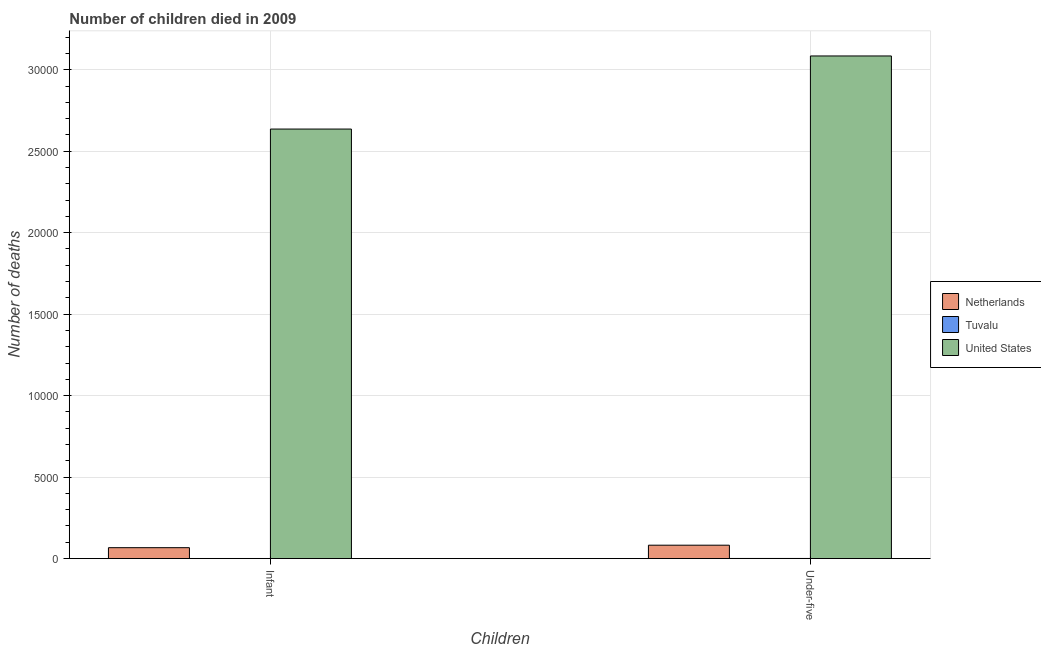Are the number of bars on each tick of the X-axis equal?
Provide a succinct answer. Yes. How many bars are there on the 2nd tick from the left?
Your answer should be very brief. 3. What is the label of the 2nd group of bars from the left?
Provide a short and direct response. Under-five. What is the number of under-five deaths in United States?
Make the answer very short. 3.08e+04. Across all countries, what is the maximum number of under-five deaths?
Provide a short and direct response. 3.08e+04. Across all countries, what is the minimum number of under-five deaths?
Make the answer very short. 7. In which country was the number of infant deaths minimum?
Your answer should be very brief. Tuvalu. What is the total number of infant deaths in the graph?
Provide a succinct answer. 2.70e+04. What is the difference between the number of infant deaths in Netherlands and that in United States?
Provide a short and direct response. -2.57e+04. What is the difference between the number of infant deaths in Tuvalu and the number of under-five deaths in United States?
Give a very brief answer. -3.08e+04. What is the average number of under-five deaths per country?
Offer a very short reply. 1.06e+04. What is the difference between the number of infant deaths and number of under-five deaths in Netherlands?
Your response must be concise. -153. What is the ratio of the number of infant deaths in Netherlands to that in Tuvalu?
Ensure brevity in your answer.  133.6. What does the 2nd bar from the left in Infant represents?
Your answer should be compact. Tuvalu. Are all the bars in the graph horizontal?
Make the answer very short. No. How many countries are there in the graph?
Keep it short and to the point. 3. What is the difference between two consecutive major ticks on the Y-axis?
Make the answer very short. 5000. Are the values on the major ticks of Y-axis written in scientific E-notation?
Give a very brief answer. No. Does the graph contain any zero values?
Offer a terse response. No. Does the graph contain grids?
Offer a terse response. Yes. Where does the legend appear in the graph?
Your answer should be compact. Center right. How many legend labels are there?
Keep it short and to the point. 3. What is the title of the graph?
Offer a terse response. Number of children died in 2009. Does "Mongolia" appear as one of the legend labels in the graph?
Your answer should be compact. No. What is the label or title of the X-axis?
Your response must be concise. Children. What is the label or title of the Y-axis?
Provide a short and direct response. Number of deaths. What is the Number of deaths of Netherlands in Infant?
Your answer should be compact. 668. What is the Number of deaths in Tuvalu in Infant?
Your answer should be very brief. 5. What is the Number of deaths in United States in Infant?
Give a very brief answer. 2.64e+04. What is the Number of deaths in Netherlands in Under-five?
Your answer should be very brief. 821. What is the Number of deaths in Tuvalu in Under-five?
Give a very brief answer. 7. What is the Number of deaths of United States in Under-five?
Make the answer very short. 3.08e+04. Across all Children, what is the maximum Number of deaths of Netherlands?
Provide a short and direct response. 821. Across all Children, what is the maximum Number of deaths of Tuvalu?
Keep it short and to the point. 7. Across all Children, what is the maximum Number of deaths in United States?
Your response must be concise. 3.08e+04. Across all Children, what is the minimum Number of deaths in Netherlands?
Make the answer very short. 668. Across all Children, what is the minimum Number of deaths of Tuvalu?
Provide a short and direct response. 5. Across all Children, what is the minimum Number of deaths in United States?
Give a very brief answer. 2.64e+04. What is the total Number of deaths of Netherlands in the graph?
Your answer should be compact. 1489. What is the total Number of deaths of United States in the graph?
Offer a very short reply. 5.72e+04. What is the difference between the Number of deaths of Netherlands in Infant and that in Under-five?
Provide a short and direct response. -153. What is the difference between the Number of deaths of Tuvalu in Infant and that in Under-five?
Ensure brevity in your answer.  -2. What is the difference between the Number of deaths in United States in Infant and that in Under-five?
Your answer should be compact. -4486. What is the difference between the Number of deaths in Netherlands in Infant and the Number of deaths in Tuvalu in Under-five?
Your answer should be very brief. 661. What is the difference between the Number of deaths of Netherlands in Infant and the Number of deaths of United States in Under-five?
Give a very brief answer. -3.02e+04. What is the difference between the Number of deaths of Tuvalu in Infant and the Number of deaths of United States in Under-five?
Your response must be concise. -3.08e+04. What is the average Number of deaths in Netherlands per Children?
Offer a terse response. 744.5. What is the average Number of deaths in Tuvalu per Children?
Ensure brevity in your answer.  6. What is the average Number of deaths in United States per Children?
Provide a succinct answer. 2.86e+04. What is the difference between the Number of deaths in Netherlands and Number of deaths in Tuvalu in Infant?
Offer a terse response. 663. What is the difference between the Number of deaths in Netherlands and Number of deaths in United States in Infant?
Offer a very short reply. -2.57e+04. What is the difference between the Number of deaths of Tuvalu and Number of deaths of United States in Infant?
Your response must be concise. -2.64e+04. What is the difference between the Number of deaths of Netherlands and Number of deaths of Tuvalu in Under-five?
Your answer should be very brief. 814. What is the difference between the Number of deaths in Netherlands and Number of deaths in United States in Under-five?
Your answer should be compact. -3.00e+04. What is the difference between the Number of deaths of Tuvalu and Number of deaths of United States in Under-five?
Offer a terse response. -3.08e+04. What is the ratio of the Number of deaths in Netherlands in Infant to that in Under-five?
Your answer should be compact. 0.81. What is the ratio of the Number of deaths of Tuvalu in Infant to that in Under-five?
Your answer should be very brief. 0.71. What is the ratio of the Number of deaths in United States in Infant to that in Under-five?
Offer a terse response. 0.85. What is the difference between the highest and the second highest Number of deaths in Netherlands?
Offer a terse response. 153. What is the difference between the highest and the second highest Number of deaths of United States?
Provide a short and direct response. 4486. What is the difference between the highest and the lowest Number of deaths in Netherlands?
Offer a terse response. 153. What is the difference between the highest and the lowest Number of deaths in United States?
Give a very brief answer. 4486. 